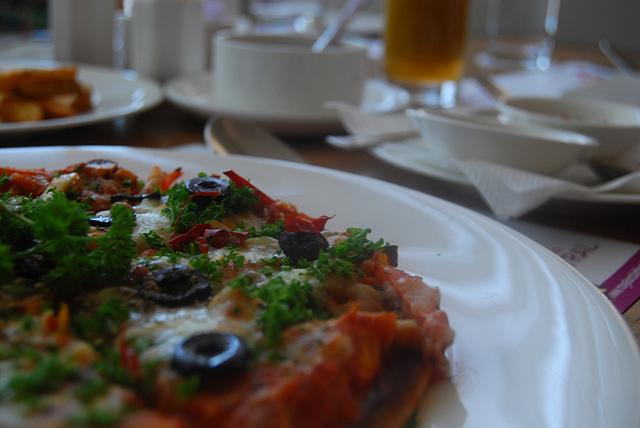What color are the olives?
Write a very short answer. Black. Are there spices available?
Be succinct. No. Is there a fork?
Keep it brief. No. What red vegetable is on the front pizza?
Keep it brief. Tomato. Is there more than one kind of beverage on the table?
Quick response, please. Yes. What green food is on the pizza?
Short answer required. Parsley. What type of food is in this picture?
Be succinct. Pizza. Is the food fried?
Short answer required. No. 